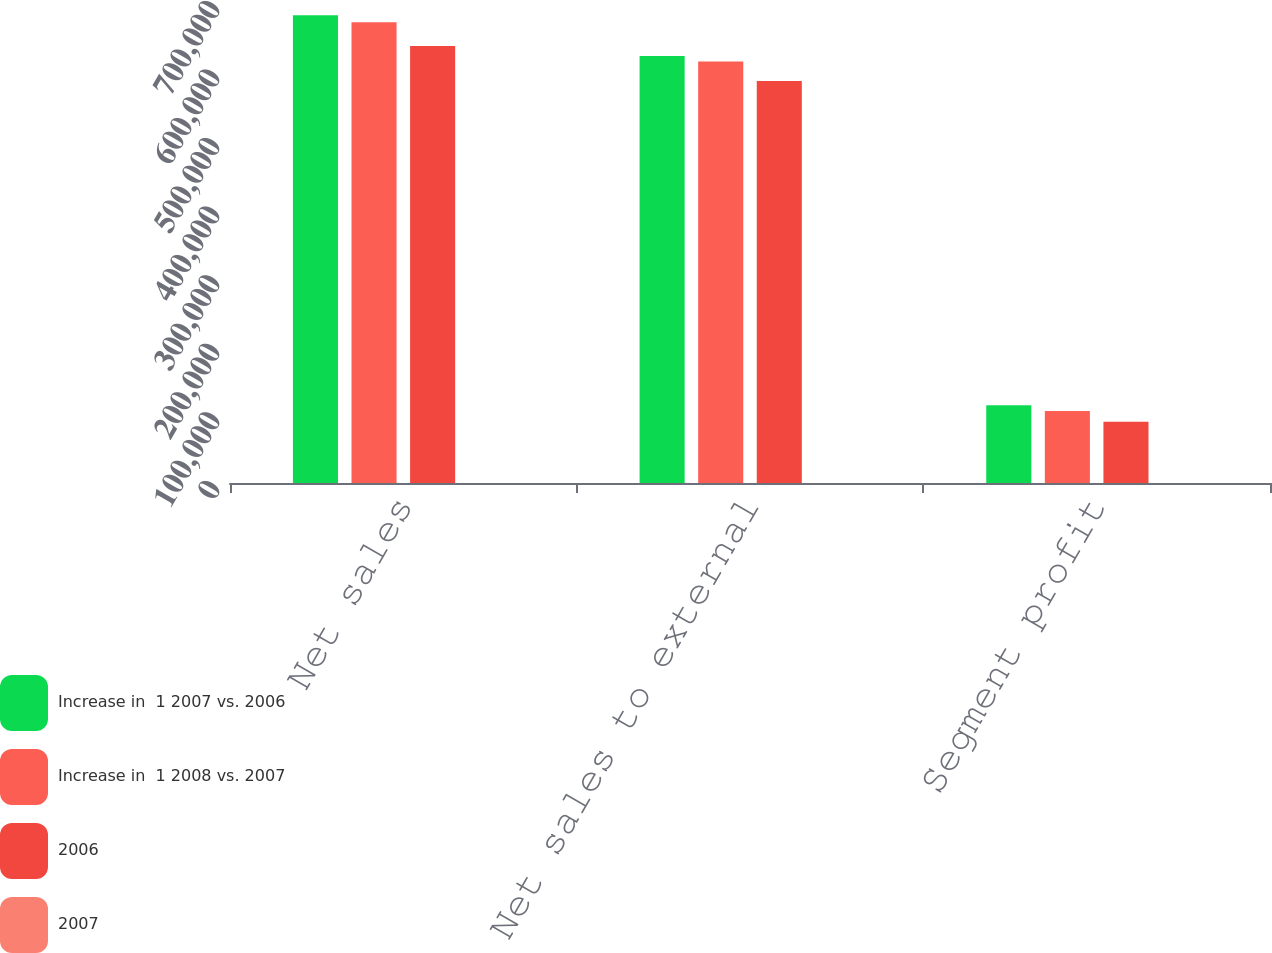Convert chart to OTSL. <chart><loc_0><loc_0><loc_500><loc_500><stacked_bar_chart><ecel><fcel>Net sales<fcel>Net sales to external<fcel>Segment profit<nl><fcel>Increase in  1 2007 vs. 2006<fcel>682282<fcel>622692<fcel>113390<nl><fcel>Increase in  1 2008 vs. 2007<fcel>671869<fcel>614735<fcel>104913<nl><fcel>2006<fcel>637418<fcel>586069<fcel>89384<nl><fcel>2007<fcel>2<fcel>1<fcel>8<nl></chart> 